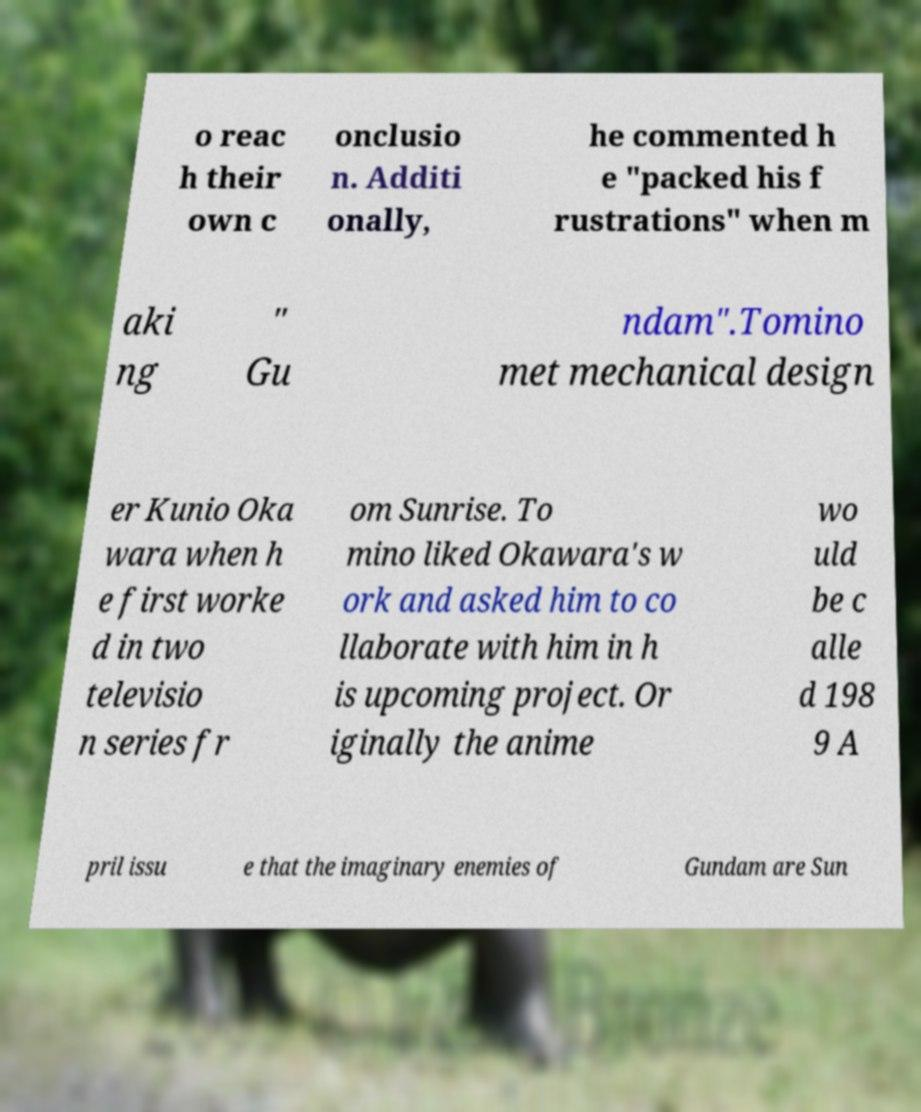Please read and relay the text visible in this image. What does it say? o reac h their own c onclusio n. Additi onally, he commented h e "packed his f rustrations" when m aki ng " Gu ndam".Tomino met mechanical design er Kunio Oka wara when h e first worke d in two televisio n series fr om Sunrise. To mino liked Okawara's w ork and asked him to co llaborate with him in h is upcoming project. Or iginally the anime wo uld be c alle d 198 9 A pril issu e that the imaginary enemies of Gundam are Sun 